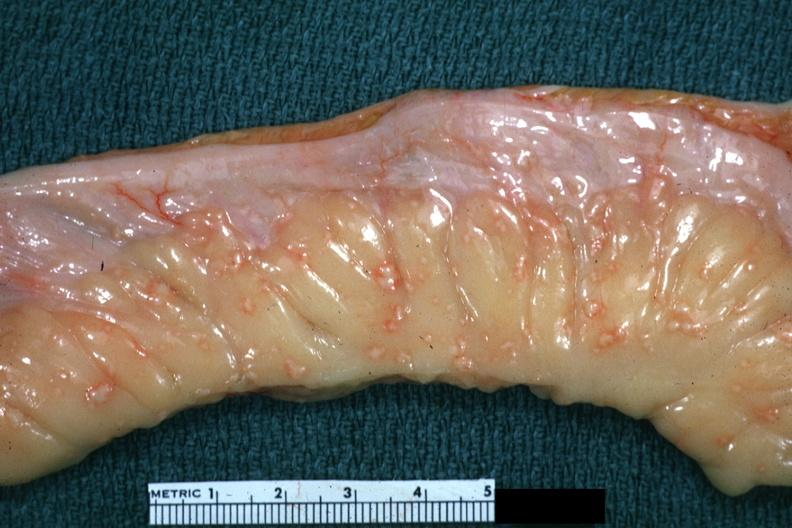where is this area in the body?
Answer the question using a single word or phrase. Abdomen 